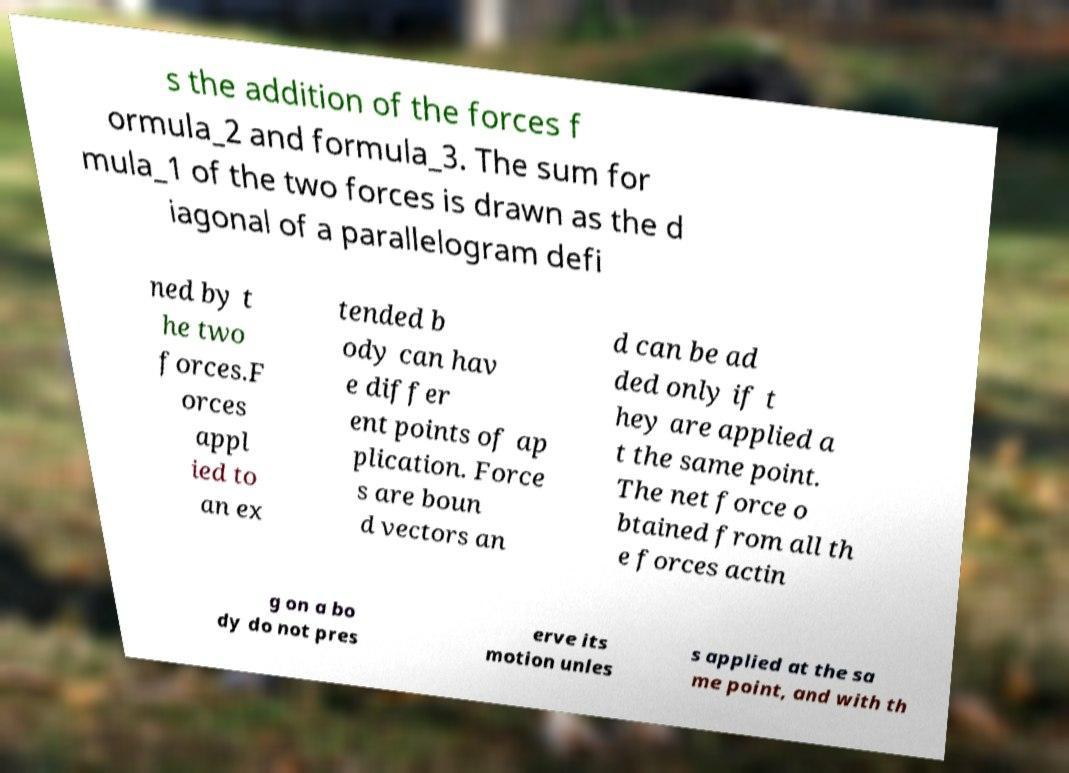What messages or text are displayed in this image? I need them in a readable, typed format. s the addition of the forces f ormula_2 and formula_3. The sum for mula_1 of the two forces is drawn as the d iagonal of a parallelogram defi ned by t he two forces.F orces appl ied to an ex tended b ody can hav e differ ent points of ap plication. Force s are boun d vectors an d can be ad ded only if t hey are applied a t the same point. The net force o btained from all th e forces actin g on a bo dy do not pres erve its motion unles s applied at the sa me point, and with th 